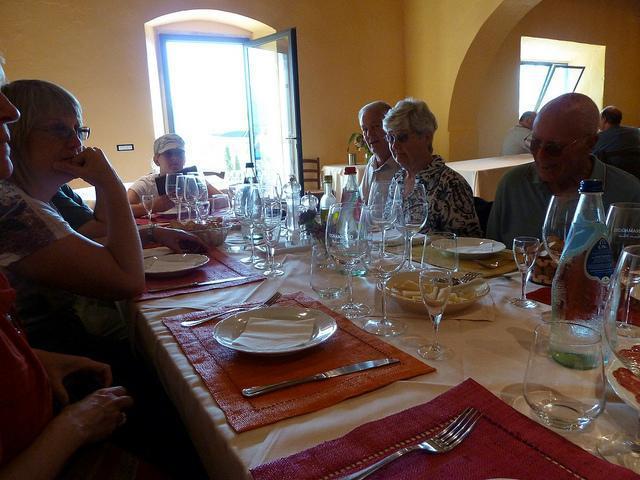How many pitchers are visible?
Give a very brief answer. 3. How many cups are there?
Give a very brief answer. 2. How many dining tables are in the picture?
Give a very brief answer. 3. How many wine glasses can you see?
Give a very brief answer. 4. How many people are there?
Give a very brief answer. 7. How many cats are sitting on the blanket?
Give a very brief answer. 0. 